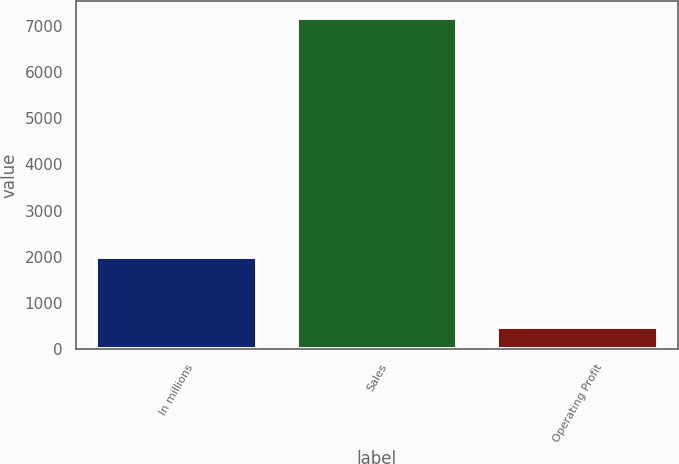<chart> <loc_0><loc_0><loc_500><loc_500><bar_chart><fcel>In millions<fcel>Sales<fcel>Operating Profit<nl><fcel>2005<fcel>7170<fcel>473<nl></chart> 